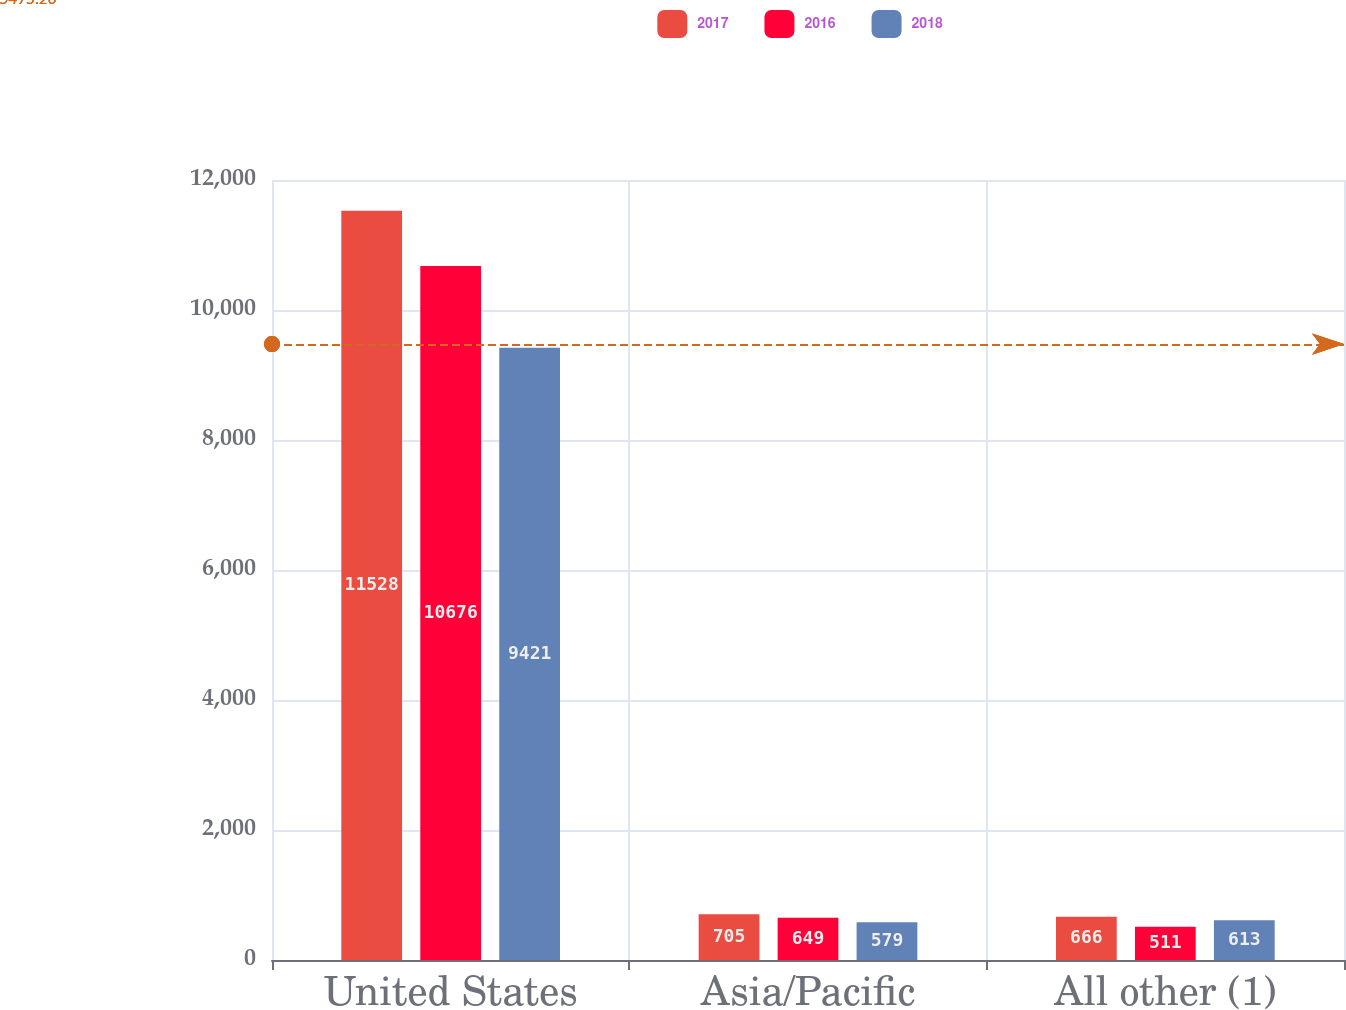<chart> <loc_0><loc_0><loc_500><loc_500><stacked_bar_chart><ecel><fcel>United States<fcel>Asia/Pacific<fcel>All other (1)<nl><fcel>2017<fcel>11528<fcel>705<fcel>666<nl><fcel>2016<fcel>10676<fcel>649<fcel>511<nl><fcel>2018<fcel>9421<fcel>579<fcel>613<nl></chart> 